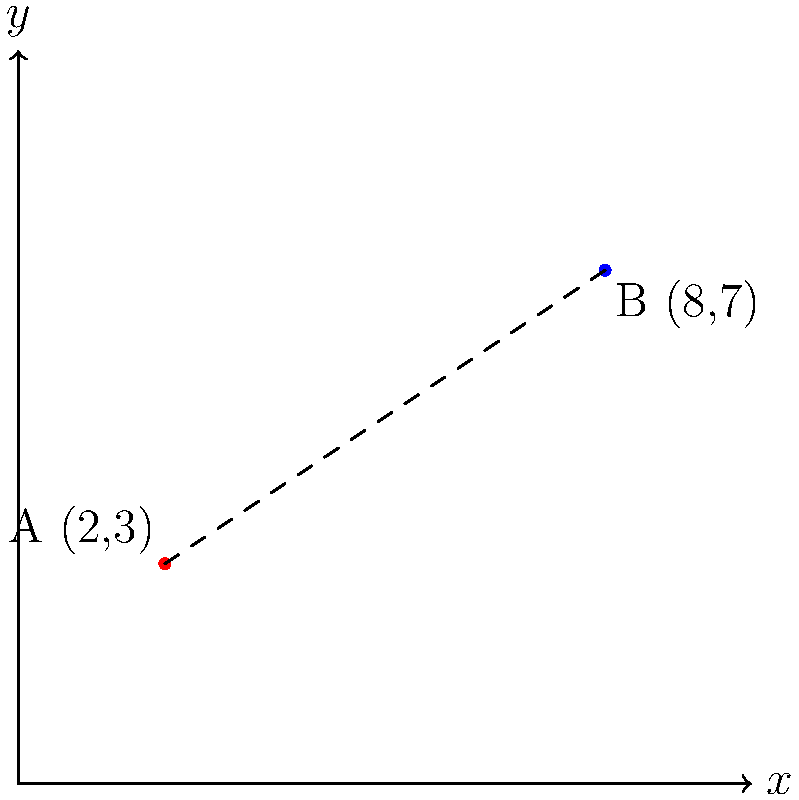Two military checkpoints, A and B, are located on a map using a Cartesian coordinate system. Checkpoint A is at coordinates (2,3) and Checkpoint B is at (8,7). Calculate the distance between these two checkpoints to the nearest tenth of a unit. How might this information be used to ensure accountability in military operations? To calculate the distance between two points in a Cartesian coordinate system, we use the distance formula, which is derived from the Pythagorean theorem:

$$ d = \sqrt{(x_2 - x_1)^2 + (y_2 - y_1)^2} $$

Where $(x_1, y_1)$ are the coordinates of the first point and $(x_2, y_2)$ are the coordinates of the second point.

Step 1: Identify the coordinates
Point A: $(x_1, y_1) = (2, 3)$
Point B: $(x_2, y_2) = (8, 7)$

Step 2: Plug the values into the distance formula
$$ d = \sqrt{(8 - 2)^2 + (7 - 3)^2} $$

Step 3: Simplify inside the parentheses
$$ d = \sqrt{6^2 + 4^2} $$

Step 4: Calculate the squares
$$ d = \sqrt{36 + 16} $$

Step 5: Add under the square root
$$ d = \sqrt{52} $$

Step 6: Calculate the square root and round to the nearest tenth
$$ d \approx 7.2 $$

The distance between the two checkpoints is approximately 7.2 units.

Regarding accountability in military operations, this information can be used to:
1. Verify the accuracy of reported checkpoint locations
2. Ensure proper spacing between checkpoints for effective area coverage
3. Calculate response times between checkpoints in emergency situations
4. Monitor movement of personnel and resources between checkpoints
5. Assess potential risks and vulnerabilities based on checkpoint proximity
Answer: 7.2 units 